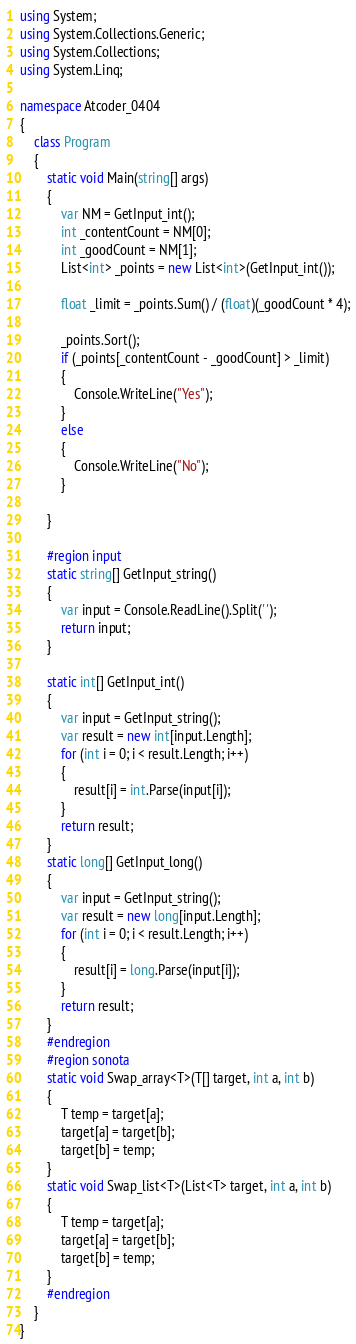<code> <loc_0><loc_0><loc_500><loc_500><_C#_>using System;
using System.Collections.Generic;
using System.Collections;
using System.Linq;

namespace Atcoder_0404
{
    class Program
    {
        static void Main(string[] args)
        {
            var NM = GetInput_int();
            int _contentCount = NM[0];
            int _goodCount = NM[1];
            List<int> _points = new List<int>(GetInput_int());

            float _limit = _points.Sum() / (float)(_goodCount * 4);

            _points.Sort();
            if (_points[_contentCount - _goodCount] > _limit)
            {
                Console.WriteLine("Yes");
            }
            else
            {
                Console.WriteLine("No");
            }
            
        }

        #region input
        static string[] GetInput_string()
        {
            var input = Console.ReadLine().Split(' ');
            return input;
        }

        static int[] GetInput_int()
        {
            var input = GetInput_string();
            var result = new int[input.Length];
            for (int i = 0; i < result.Length; i++)
            {
                result[i] = int.Parse(input[i]);
            }
            return result;
        }
        static long[] GetInput_long()
        {
            var input = GetInput_string();
            var result = new long[input.Length];
            for (int i = 0; i < result.Length; i++)
            {
                result[i] = long.Parse(input[i]);
            }
            return result;
        }
        #endregion
        #region sonota
        static void Swap_array<T>(T[] target, int a, int b)
        {
            T temp = target[a];
            target[a] = target[b];
            target[b] = temp;
        }
        static void Swap_list<T>(List<T> target, int a, int b)
        {
            T temp = target[a];
            target[a] = target[b];
            target[b] = temp;
        }
        #endregion
    }
}</code> 